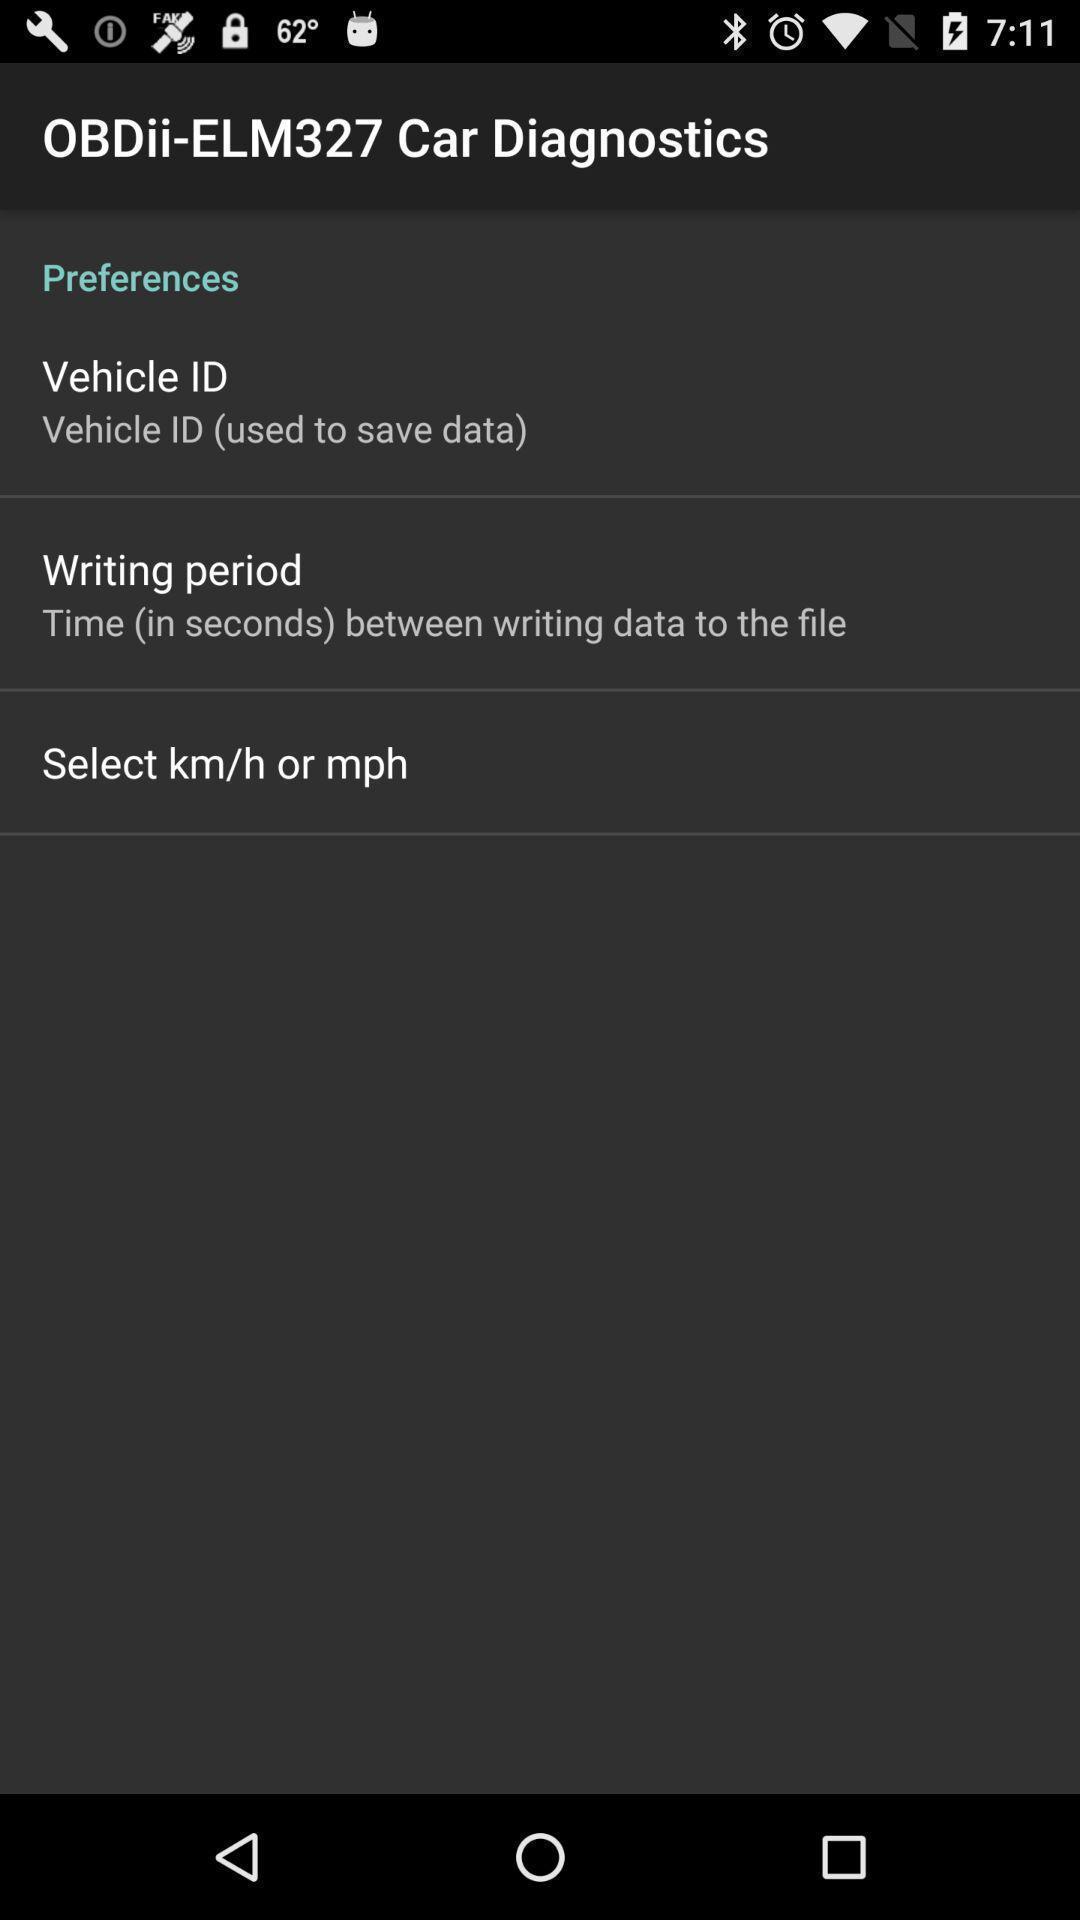Provide a detailed account of this screenshot. Screen displaying preferences information of a vehicle. 